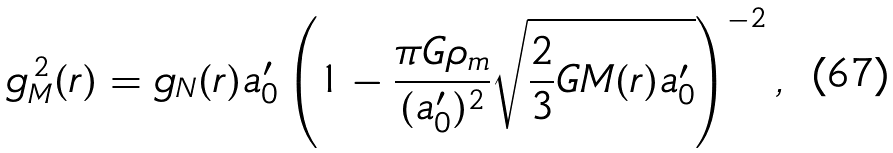Convert formula to latex. <formula><loc_0><loc_0><loc_500><loc_500>g _ { M } ^ { \, 2 } ( r ) = g _ { N } ( r ) a _ { 0 } ^ { \prime } \left ( 1 - \frac { \pi G \rho _ { m } } { ( a _ { 0 } ^ { \prime } ) ^ { 2 } } \sqrt { \frac { 2 } { 3 } G M ( r ) a _ { 0 } ^ { \prime } } \right ) ^ { - 2 } ,</formula> 